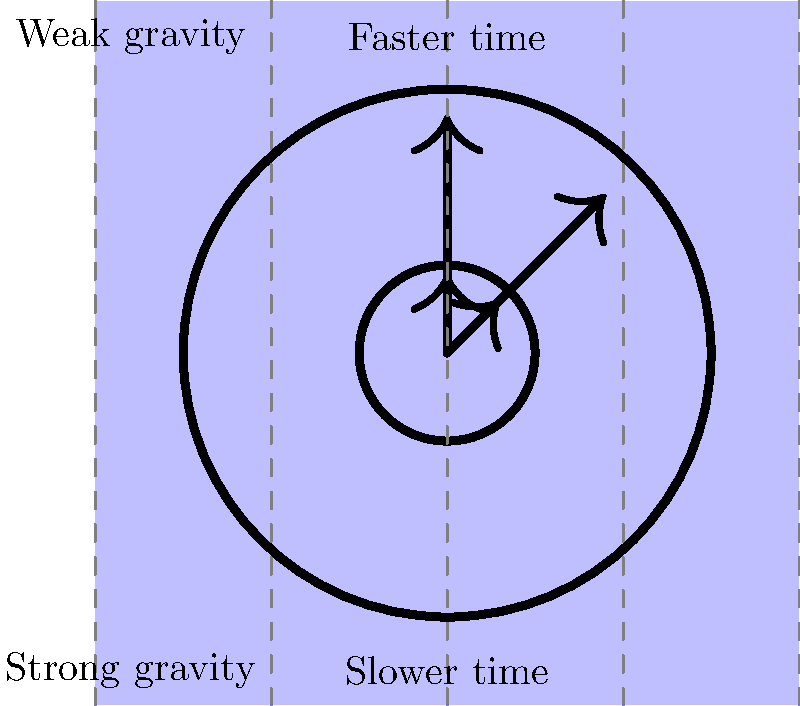In your time-traveling adventures, you encounter a peculiar phenomenon where aging spells behave differently in various gravitational fields. How would the effectiveness of an aging spell cast on two identical wizards be affected if one wizard is near a massive celestial body (represented by the larger clock) and the other is in deep space (represented by the smaller clock)? To understand the effect of gravitational time dilation on aging spells, we need to consider the following steps:

1. Gravitational time dilation: According to Einstein's theory of general relativity, time passes more slowly in stronger gravitational fields. This is represented in the diagram by the larger clock (slower time) in the area of stronger gravity and the smaller clock (faster time) in the area of weaker gravity.

2. Aging spells and time: Assume that aging spells work by accelerating the natural passage of time for the target.

3. Spell effectiveness near the massive celestial body:
   - The wizard near the massive body experiences slower time passage due to stronger gravity.
   - The aging spell attempts to accelerate time for this wizard.
   - However, the strong gravitational field counteracts some of the spell's effects.

4. Spell effectiveness in deep space:
   - The wizard in deep space experiences normal time passage due to weak gravity.
   - The aging spell accelerates time for this wizard without much interference.

5. Comparative effect:
   - The spell cast on the wizard in deep space will be more effective, causing more rapid aging.
   - The spell cast on the wizard near the massive body will be less effective, resulting in slower aging compared to the wizard in deep space.

6. Quantification: The difference in aging rate can be calculated using the time dilation formula:
   
   $$t' = t \sqrt{1 - \frac{2GM}{rc^2}}$$
   
   Where $t'$ is the time experienced in the stronger gravitational field, $t$ is the time experienced in the weaker field, $G$ is the gravitational constant, $M$ is the mass of the celestial body, $r$ is the distance from the center of the celestial body, and $c$ is the speed of light.

In conclusion, the aging spell would be more effective on the wizard in deep space, causing faster aging, while the wizard near the massive celestial body would age more slowly due to the counteracting effect of gravitational time dilation.
Answer: The aging spell is more effective in deep space, causing faster aging compared to near the massive celestial body. 